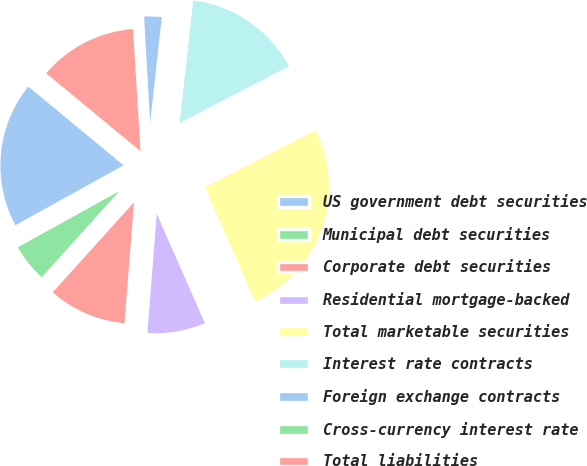<chart> <loc_0><loc_0><loc_500><loc_500><pie_chart><fcel>US government debt securities<fcel>Municipal debt securities<fcel>Corporate debt securities<fcel>Residential mortgage-backed<fcel>Total marketable securities<fcel>Interest rate contracts<fcel>Foreign exchange contracts<fcel>Cross-currency interest rate<fcel>Total liabilities<nl><fcel>19.04%<fcel>5.26%<fcel>10.44%<fcel>7.85%<fcel>26.01%<fcel>15.63%<fcel>2.66%<fcel>0.07%<fcel>13.04%<nl></chart> 